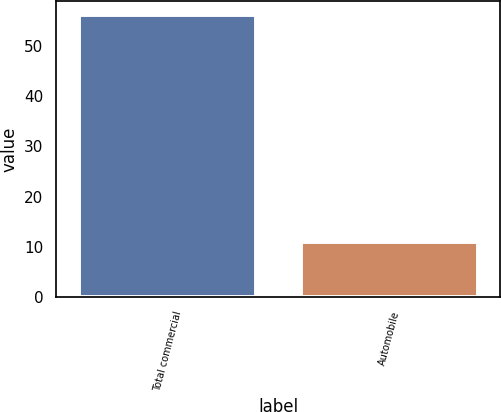Convert chart to OTSL. <chart><loc_0><loc_0><loc_500><loc_500><bar_chart><fcel>Total commercial<fcel>Automobile<nl><fcel>56<fcel>11<nl></chart> 